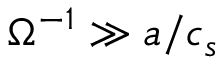<formula> <loc_0><loc_0><loc_500><loc_500>\Omega ^ { - 1 } \gg a / c _ { s }</formula> 